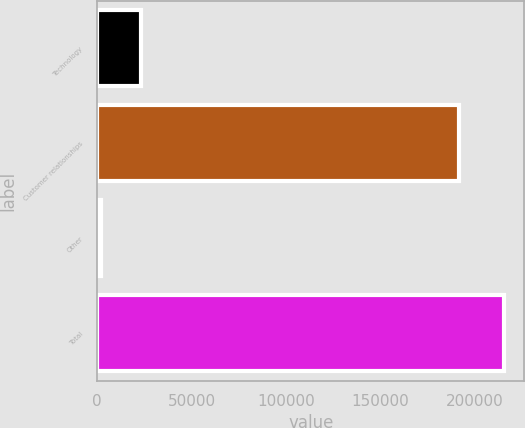Convert chart to OTSL. <chart><loc_0><loc_0><loc_500><loc_500><bar_chart><fcel>Technology<fcel>Customer relationships<fcel>Other<fcel>Total<nl><fcel>23222.7<fcel>191625<fcel>1861<fcel>215478<nl></chart> 